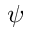Convert formula to latex. <formula><loc_0><loc_0><loc_500><loc_500>\psi</formula> 